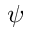Convert formula to latex. <formula><loc_0><loc_0><loc_500><loc_500>\psi</formula> 